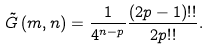Convert formula to latex. <formula><loc_0><loc_0><loc_500><loc_500>\tilde { G } \left ( m , n \right ) = \frac { 1 } { 4 ^ { n - p } } \frac { ( 2 p - 1 ) ! ! } { 2 p ! ! } .</formula> 